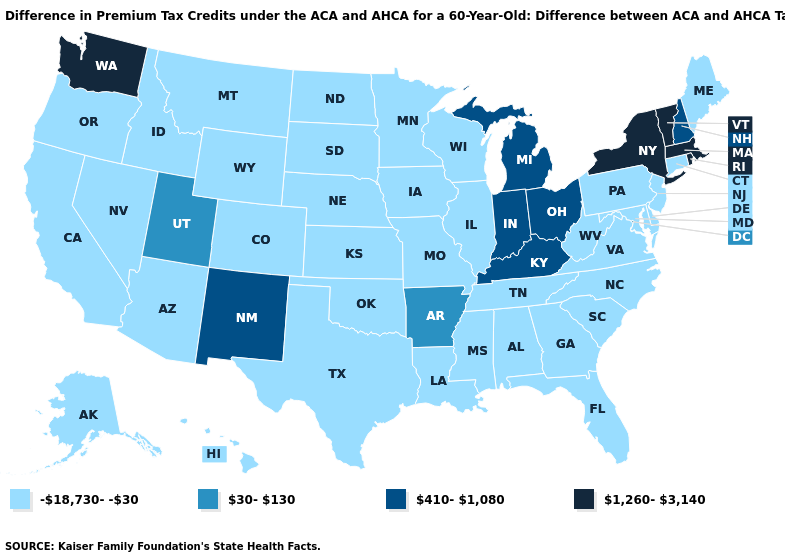Does Maine have the lowest value in the Northeast?
Give a very brief answer. Yes. Name the states that have a value in the range 410-1,080?
Concise answer only. Indiana, Kentucky, Michigan, New Hampshire, New Mexico, Ohio. Name the states that have a value in the range 410-1,080?
Short answer required. Indiana, Kentucky, Michigan, New Hampshire, New Mexico, Ohio. What is the lowest value in the USA?
Quick response, please. -18,730--30. Name the states that have a value in the range -18,730--30?
Quick response, please. Alabama, Alaska, Arizona, California, Colorado, Connecticut, Delaware, Florida, Georgia, Hawaii, Idaho, Illinois, Iowa, Kansas, Louisiana, Maine, Maryland, Minnesota, Mississippi, Missouri, Montana, Nebraska, Nevada, New Jersey, North Carolina, North Dakota, Oklahoma, Oregon, Pennsylvania, South Carolina, South Dakota, Tennessee, Texas, Virginia, West Virginia, Wisconsin, Wyoming. Name the states that have a value in the range 410-1,080?
Give a very brief answer. Indiana, Kentucky, Michigan, New Hampshire, New Mexico, Ohio. What is the highest value in states that border Vermont?
Answer briefly. 1,260-3,140. Name the states that have a value in the range 410-1,080?
Write a very short answer. Indiana, Kentucky, Michigan, New Hampshire, New Mexico, Ohio. What is the highest value in the USA?
Keep it brief. 1,260-3,140. Name the states that have a value in the range -18,730--30?
Concise answer only. Alabama, Alaska, Arizona, California, Colorado, Connecticut, Delaware, Florida, Georgia, Hawaii, Idaho, Illinois, Iowa, Kansas, Louisiana, Maine, Maryland, Minnesota, Mississippi, Missouri, Montana, Nebraska, Nevada, New Jersey, North Carolina, North Dakota, Oklahoma, Oregon, Pennsylvania, South Carolina, South Dakota, Tennessee, Texas, Virginia, West Virginia, Wisconsin, Wyoming. Is the legend a continuous bar?
Concise answer only. No. Among the states that border North Carolina , which have the highest value?
Answer briefly. Georgia, South Carolina, Tennessee, Virginia. Does Kentucky have the lowest value in the South?
Write a very short answer. No. Which states have the lowest value in the MidWest?
Keep it brief. Illinois, Iowa, Kansas, Minnesota, Missouri, Nebraska, North Dakota, South Dakota, Wisconsin. 